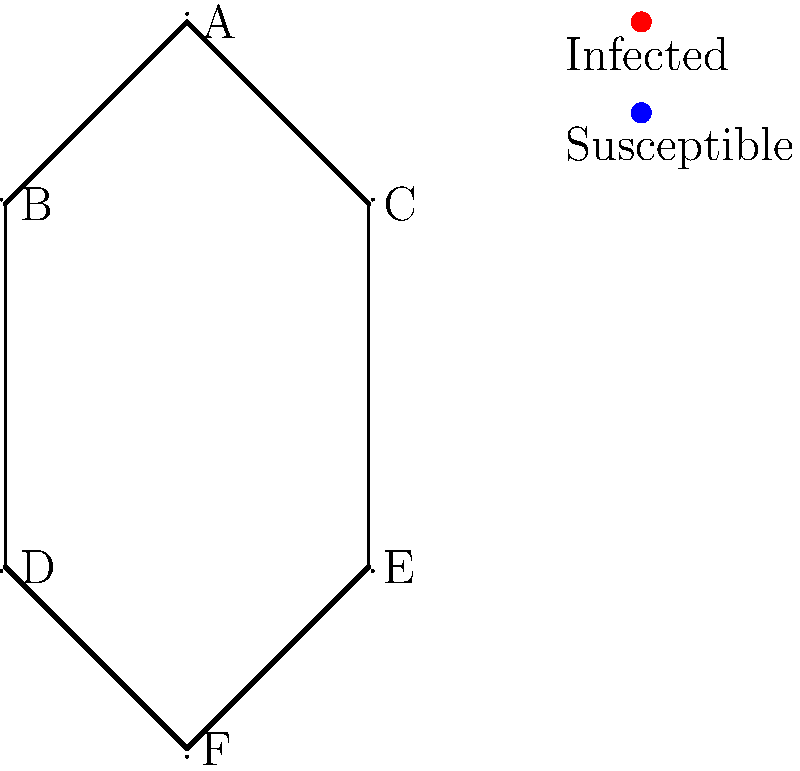In the network graph representing a population, node A is initially infected with a disease. The transmission probability along thick edges is 0.8, and along thin edges is 0.4. What is the probability that node F becomes infected if the disease spreads for exactly two time steps? To solve this problem, we need to follow these steps:

1. Identify all possible paths from A to F that take exactly two steps:
   - A → B → D → F
   - A → C → E → F

2. Calculate the probability of infection for each path:
   - Path 1 (A → B → D → F):
     P(A → B) = 0.8 (thick edge)
     P(B → D) = 0.4 (thin edge)
     P(D → F) = 0.8 (thick edge)
     P(Path 1) = 0.8 × 0.4 × 0.8 = 0.256

   - Path 2 (A → C → E → F):
     P(A → C) = 0.8 (thick edge)
     P(C → E) = 0.4 (thin edge)
     P(E → F) = 0.8 (thick edge)
     P(Path 2) = 0.8 × 0.4 × 0.8 = 0.256

3. Calculate the probability that F becomes infected:
   P(F infected) = 1 - P(F not infected)
   P(F not infected) = (1 - P(Path 1)) × (1 - P(Path 2))
   P(F not infected) = (1 - 0.256) × (1 - 0.256) = 0.744 × 0.744 = 0.5535

   P(F infected) = 1 - 0.5535 = 0.4465

Therefore, the probability that node F becomes infected after exactly two time steps is approximately 0.4465 or 44.65%.
Answer: 0.4465 (or 44.65%) 